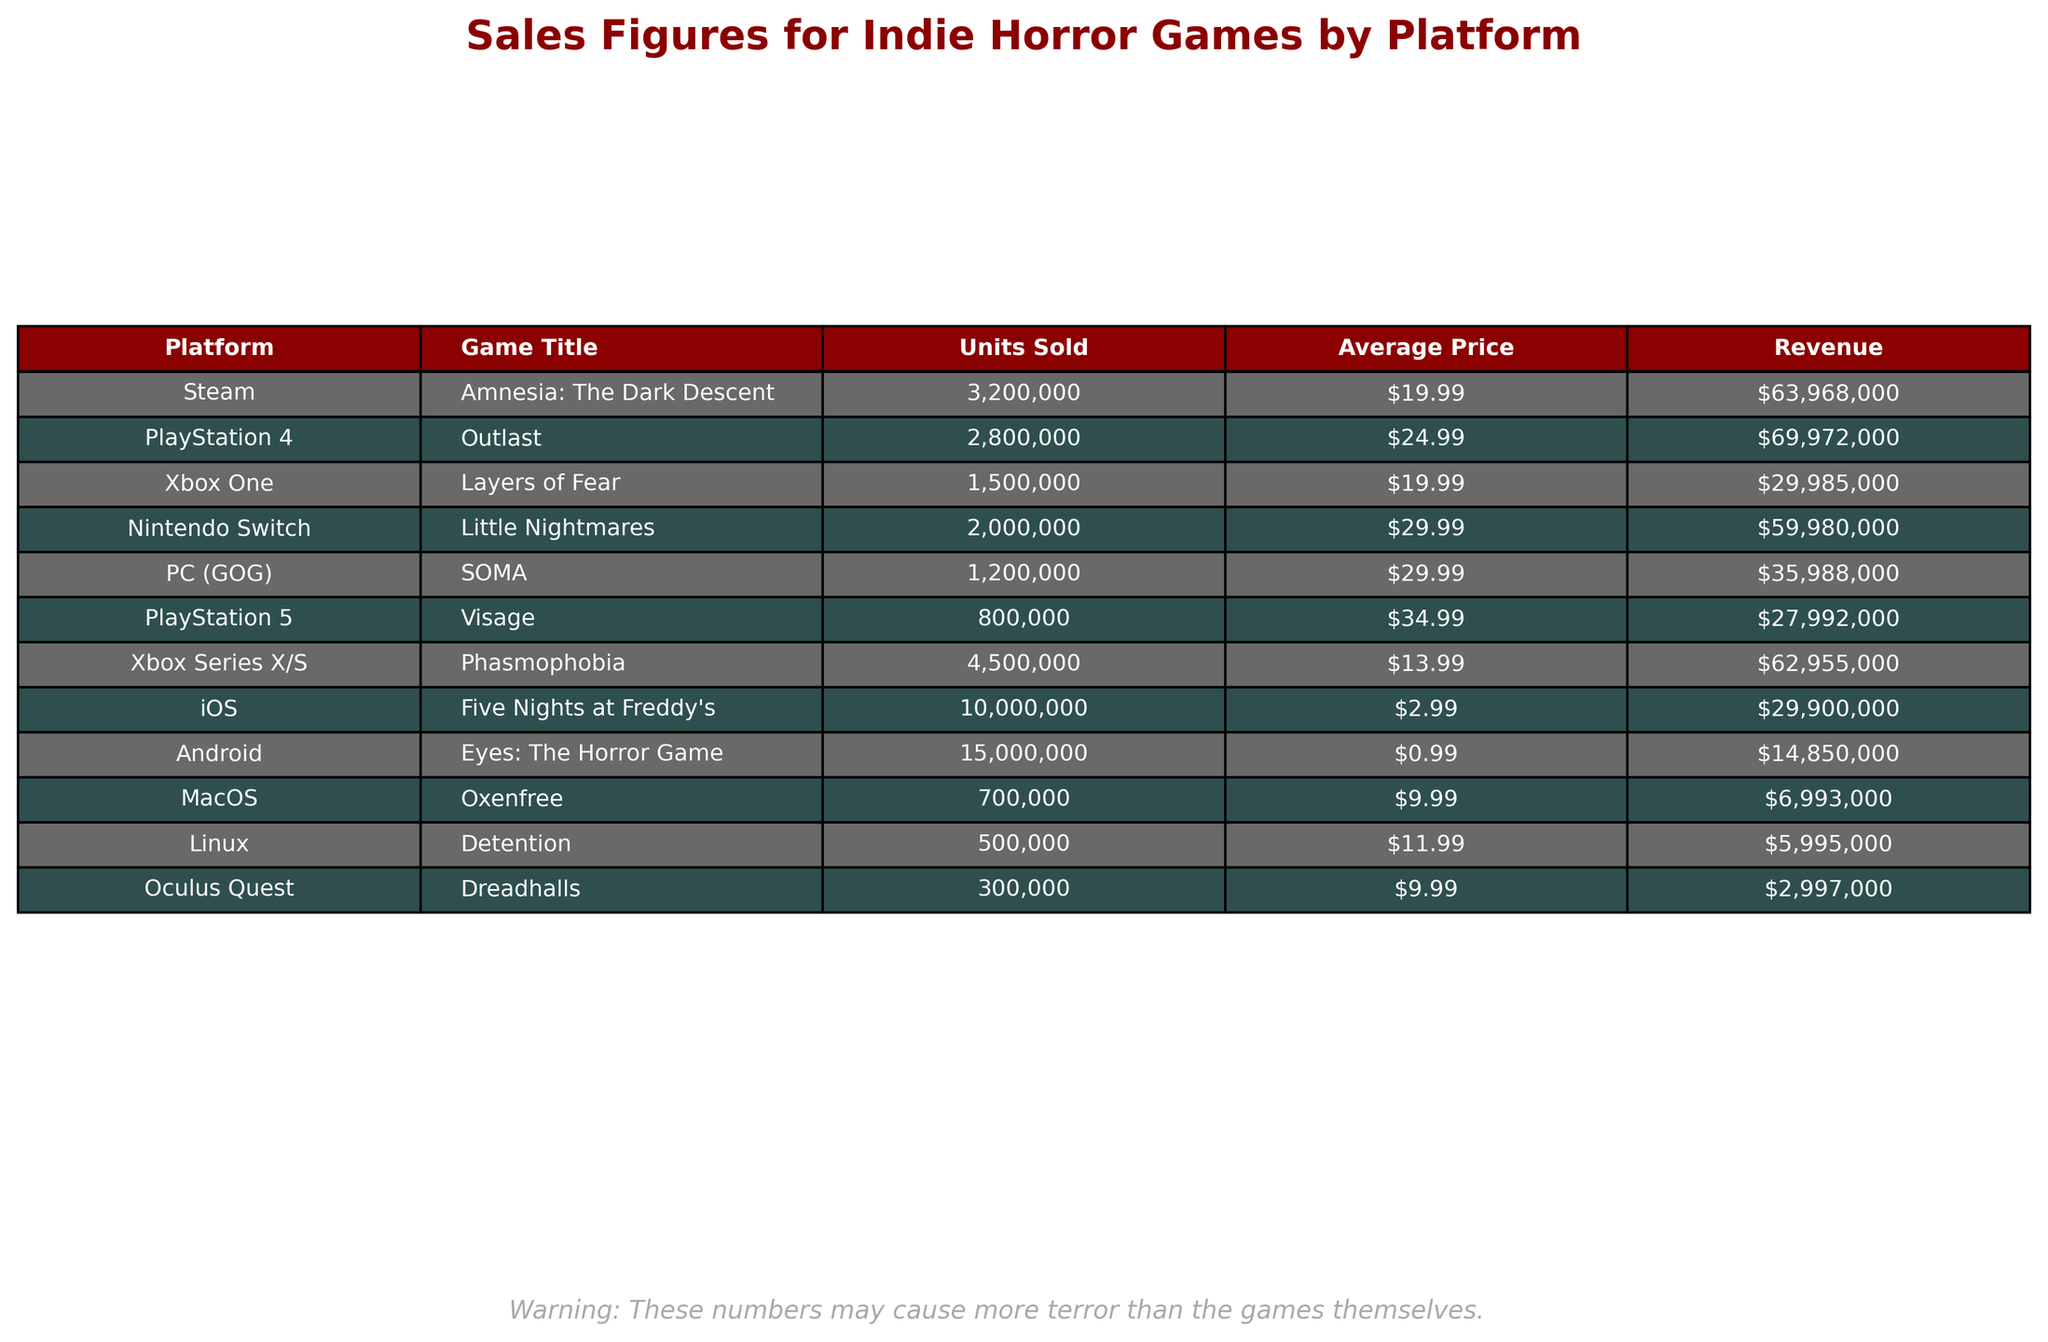What is the total revenue for all the games listed in the table? To find the total revenue, sum the revenue figures for all platforms: $63,968,000 + $69,972,000 + $29,985,000 + $59,980,000 + $35,988,000 + $27,992,000 + $62,955,000 + $29,900,000 + $14,850,000 + $6,993,000 + $5,995,000 + $2,997,000 = $ 593,907,000
Answer: $593,907,000 Which game sold the most units? The game with the highest units sold is Five Nights at Freddy's with 10,000,000 units sold, which can be found in the "Units Sold" column.
Answer: Five Nights at Freddy's Is the average price of Outlast higher than that of Layers of Fear? For Outlast, the average price is $24.99, while for Layers of Fear, it is $19.99. Since $24.99 > $19.99, the statement is true.
Answer: Yes What is the difference in revenue between Eyes: The Horror Game and Detention? The revenue for Eyes: The Horror Game is $14,850,000, and for Detention it's $5,995,000. The difference is $14,850,000 - $5,995,000 = $8,855,000.
Answer: $8,855,000 How many more units did Phasmophobia sell than Visage? Phasmophobia sold 4,500,000 units and Visage sold 800,000 units. The difference is 4,500,000 - 800,000 = 3,700,000 units.
Answer: 3,700,000 What percentage of total units sold does Five Nights at Freddy's represent? Five Nights at Freddy's sold 10,000,000 units. The total units sold across all games can be calculated (32,000,000). The percentage is (10,000,000 / 32,000,000) * 100 = 31.25%.
Answer: 31.25% Which platform generated the highest revenue? By checking the revenue column, Steam has generated $63,968,000, PlayStation 4 $69,972,000, and Xbox Series X/S $62,955,000. The highest revenue is from PlayStation 4.
Answer: PlayStation 4 Is the average price of games on Android lower than on iOS? The average price on Android is $0.99, while on iOS it's $2.99. Since $0.99 < $2.99, the statement is true.
Answer: Yes What is the total units sold for games on PC? Only one game is listed under PC (GOG), which is SOMA with 1,200,000 units sold. Therefore, the total for PC is simply 1,200,000.
Answer: 1,200,000 Calculate the average revenue for games sold on PlayStation platforms. The total revenue for PlayStation 4 is $69,972,000 and for PlayStation 5 is $27,992,000. The average revenue is ($69,972,000 + $27,992,000) / 2 = $48,982,000.
Answer: $48,982,000 